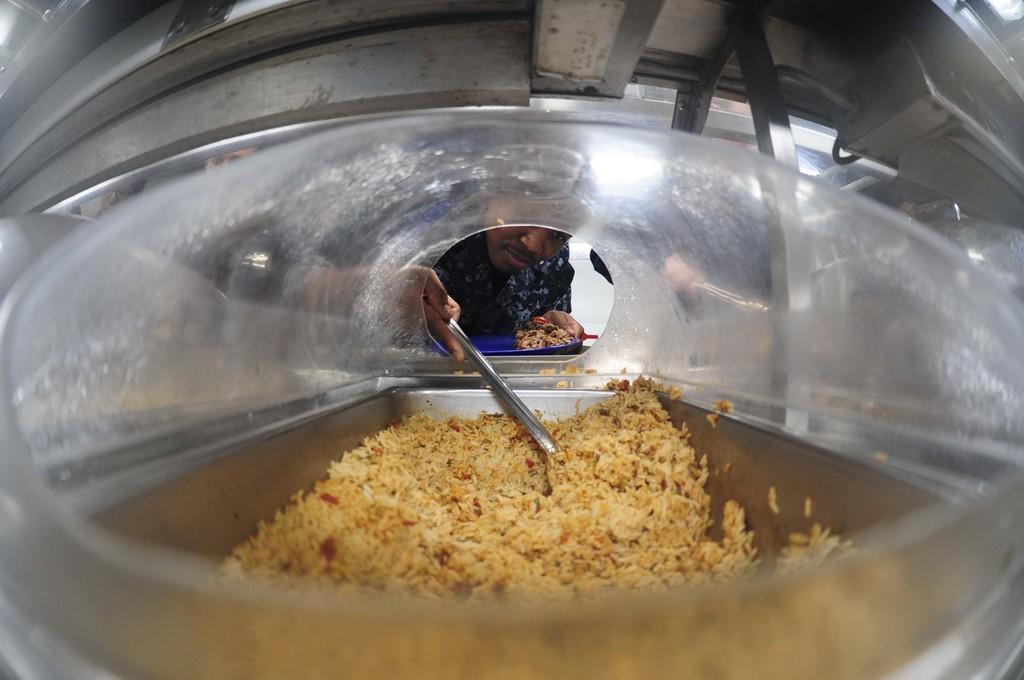Can you describe this image briefly? In the center of the image we can see a man holding a plate with some food and a spatula. We can also see some food in a steel container. 